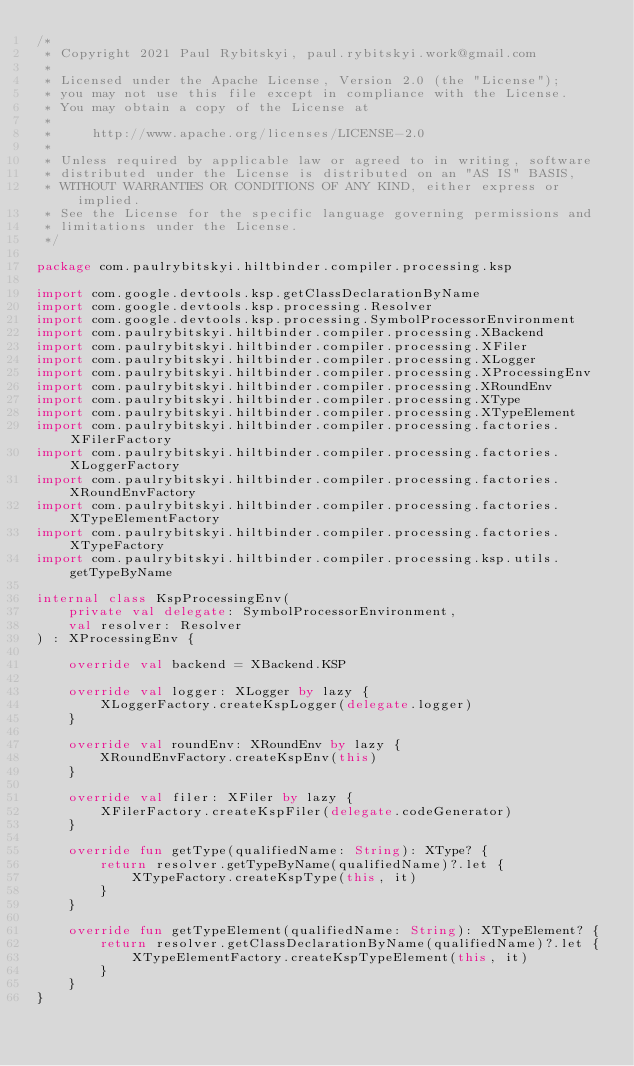<code> <loc_0><loc_0><loc_500><loc_500><_Kotlin_>/*
 * Copyright 2021 Paul Rybitskyi, paul.rybitskyi.work@gmail.com
 *
 * Licensed under the Apache License, Version 2.0 (the "License");
 * you may not use this file except in compliance with the License.
 * You may obtain a copy of the License at
 *
 *     http://www.apache.org/licenses/LICENSE-2.0
 *
 * Unless required by applicable law or agreed to in writing, software
 * distributed under the License is distributed on an "AS IS" BASIS,
 * WITHOUT WARRANTIES OR CONDITIONS OF ANY KIND, either express or implied.
 * See the License for the specific language governing permissions and
 * limitations under the License.
 */

package com.paulrybitskyi.hiltbinder.compiler.processing.ksp

import com.google.devtools.ksp.getClassDeclarationByName
import com.google.devtools.ksp.processing.Resolver
import com.google.devtools.ksp.processing.SymbolProcessorEnvironment
import com.paulrybitskyi.hiltbinder.compiler.processing.XBackend
import com.paulrybitskyi.hiltbinder.compiler.processing.XFiler
import com.paulrybitskyi.hiltbinder.compiler.processing.XLogger
import com.paulrybitskyi.hiltbinder.compiler.processing.XProcessingEnv
import com.paulrybitskyi.hiltbinder.compiler.processing.XRoundEnv
import com.paulrybitskyi.hiltbinder.compiler.processing.XType
import com.paulrybitskyi.hiltbinder.compiler.processing.XTypeElement
import com.paulrybitskyi.hiltbinder.compiler.processing.factories.XFilerFactory
import com.paulrybitskyi.hiltbinder.compiler.processing.factories.XLoggerFactory
import com.paulrybitskyi.hiltbinder.compiler.processing.factories.XRoundEnvFactory
import com.paulrybitskyi.hiltbinder.compiler.processing.factories.XTypeElementFactory
import com.paulrybitskyi.hiltbinder.compiler.processing.factories.XTypeFactory
import com.paulrybitskyi.hiltbinder.compiler.processing.ksp.utils.getTypeByName

internal class KspProcessingEnv(
    private val delegate: SymbolProcessorEnvironment,
    val resolver: Resolver
) : XProcessingEnv {

    override val backend = XBackend.KSP

    override val logger: XLogger by lazy {
        XLoggerFactory.createKspLogger(delegate.logger)
    }

    override val roundEnv: XRoundEnv by lazy {
        XRoundEnvFactory.createKspEnv(this)
    }

    override val filer: XFiler by lazy {
        XFilerFactory.createKspFiler(delegate.codeGenerator)
    }

    override fun getType(qualifiedName: String): XType? {
        return resolver.getTypeByName(qualifiedName)?.let {
            XTypeFactory.createKspType(this, it)
        }
    }

    override fun getTypeElement(qualifiedName: String): XTypeElement? {
        return resolver.getClassDeclarationByName(qualifiedName)?.let {
            XTypeElementFactory.createKspTypeElement(this, it)
        }
    }
}
</code> 